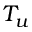Convert formula to latex. <formula><loc_0><loc_0><loc_500><loc_500>T _ { u }</formula> 